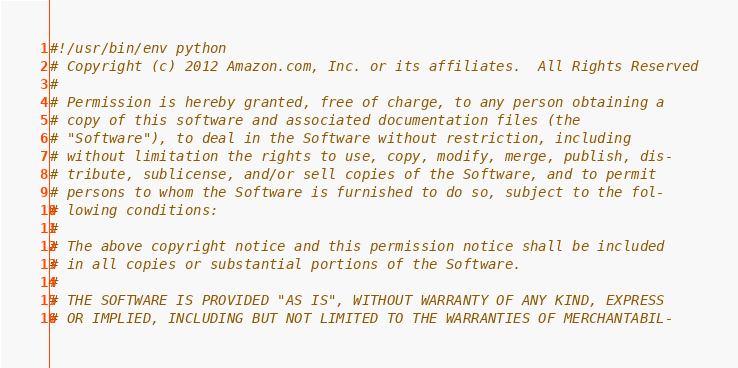Convert code to text. <code><loc_0><loc_0><loc_500><loc_500><_Python_>#!/usr/bin/env python
# Copyright (c) 2012 Amazon.com, Inc. or its affiliates.  All Rights Reserved
#
# Permission is hereby granted, free of charge, to any person obtaining a
# copy of this software and associated documentation files (the
# "Software"), to deal in the Software without restriction, including
# without limitation the rights to use, copy, modify, merge, publish, dis-
# tribute, sublicense, and/or sell copies of the Software, and to permit
# persons to whom the Software is furnished to do so, subject to the fol-
# lowing conditions:
#
# The above copyright notice and this permission notice shall be included
# in all copies or substantial portions of the Software.
#
# THE SOFTWARE IS PROVIDED "AS IS", WITHOUT WARRANTY OF ANY KIND, EXPRESS
# OR IMPLIED, INCLUDING BUT NOT LIMITED TO THE WARRANTIES OF MERCHANTABIL-</code> 